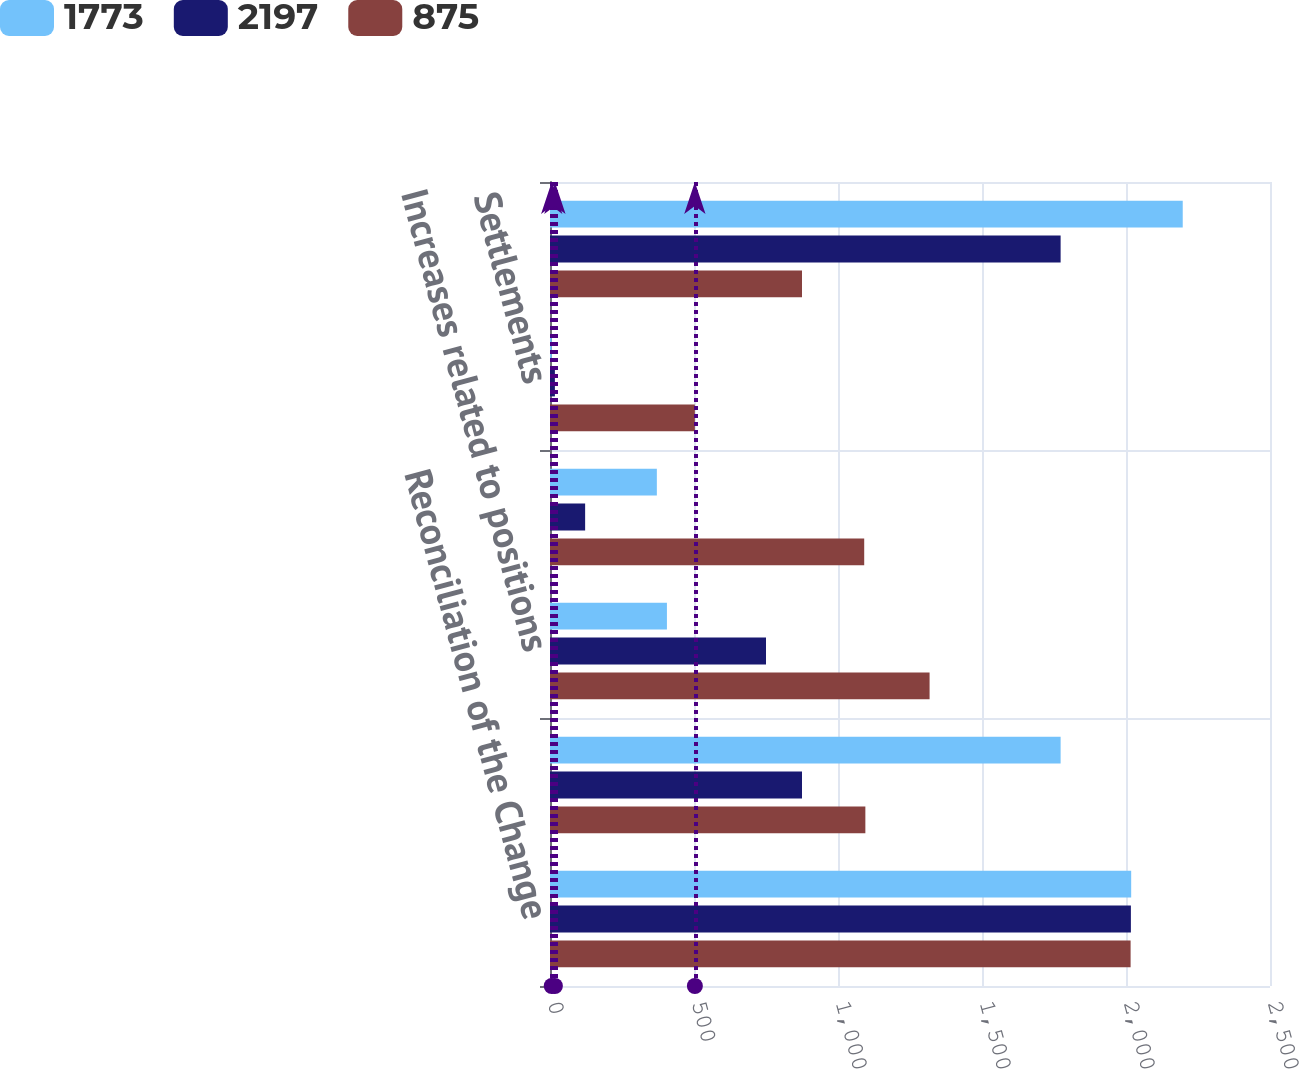<chart> <loc_0><loc_0><loc_500><loc_500><stacked_bar_chart><ecel><fcel>Reconciliation of the Change<fcel>Balance January 1<fcel>Increases related to positions<fcel>Decreases related to positions<fcel>Settlements<fcel>Balance December 31<nl><fcel>1773<fcel>2018<fcel>1773<fcel>406<fcel>371<fcel>6<fcel>2197<nl><fcel>2197<fcel>2017<fcel>875<fcel>750<fcel>122<fcel>17<fcel>1773<nl><fcel>875<fcel>2016<fcel>1095<fcel>1318<fcel>1091<fcel>503<fcel>875<nl></chart> 